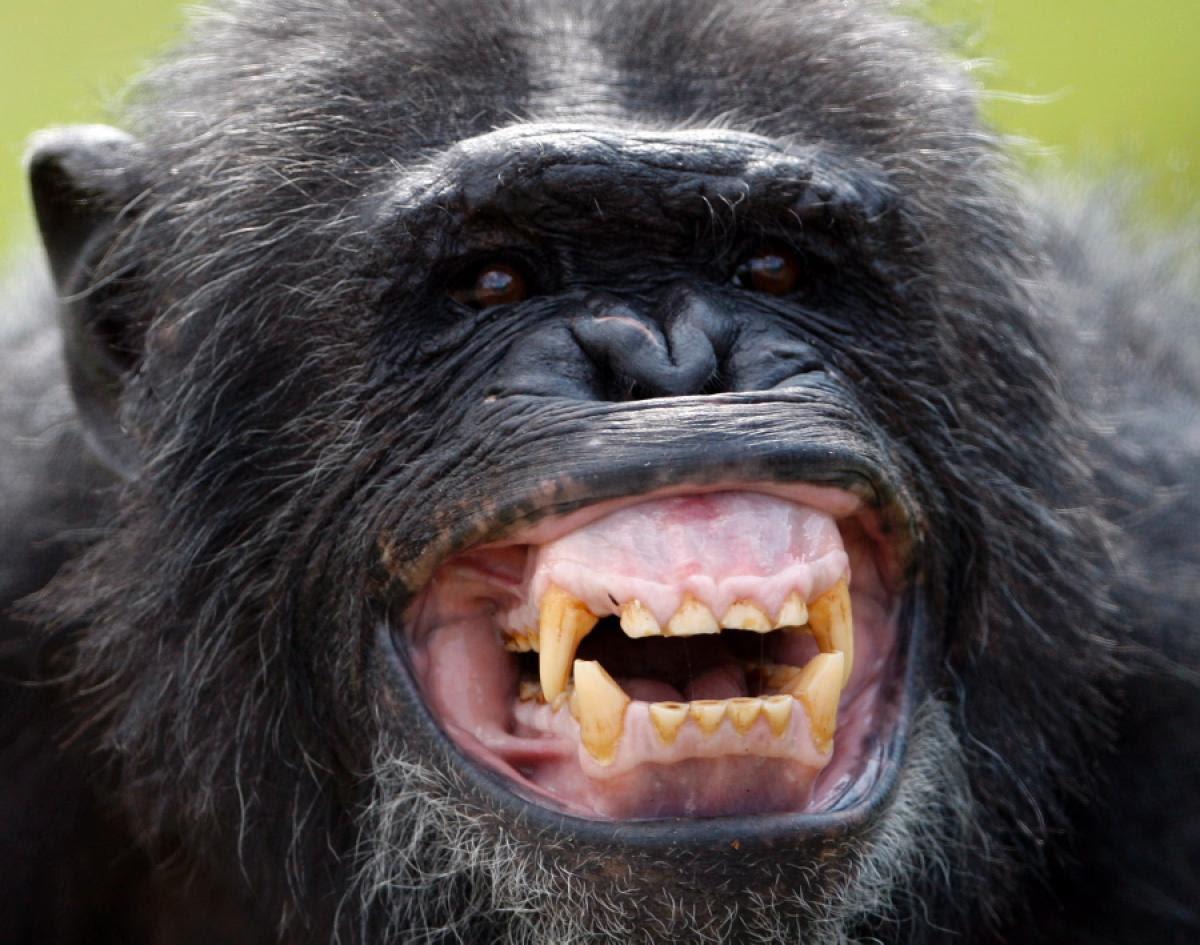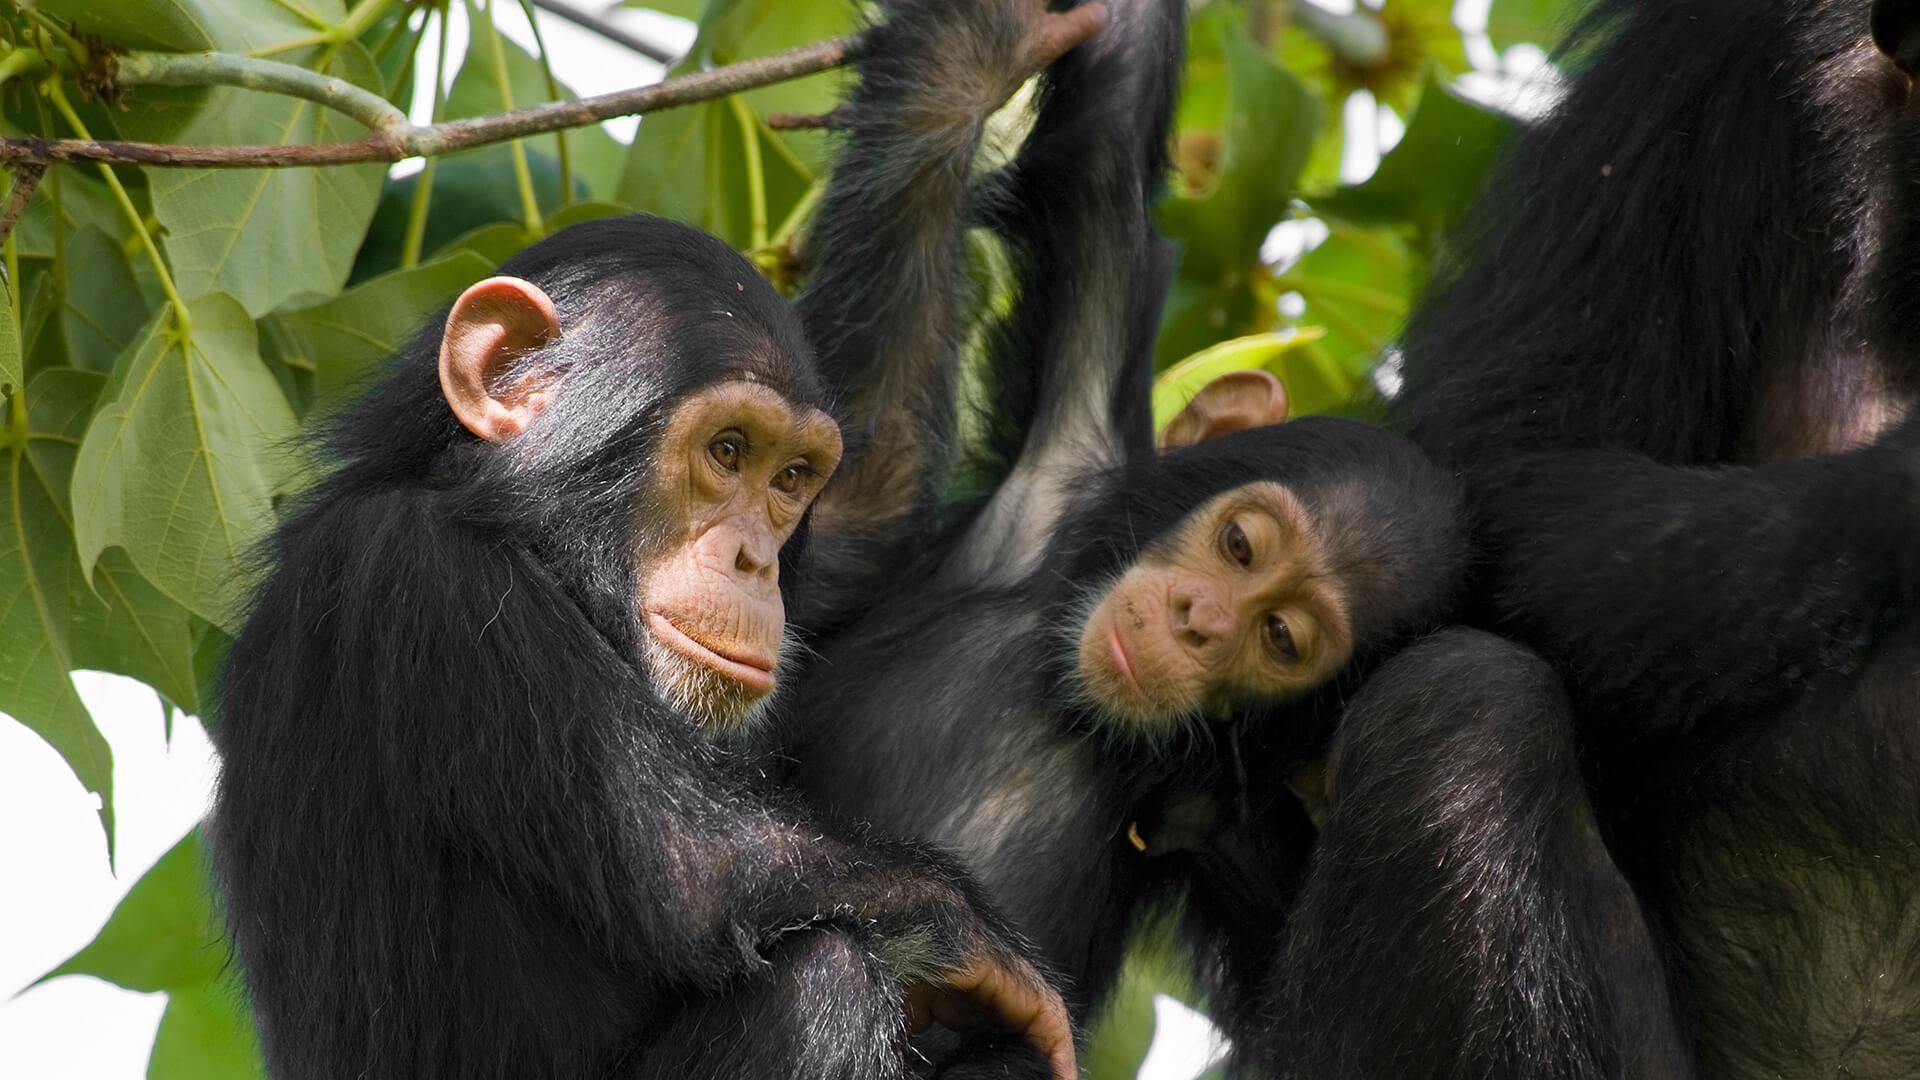The first image is the image on the left, the second image is the image on the right. For the images displayed, is the sentence "One of the images shows only one animal." factually correct? Answer yes or no. Yes. The first image is the image on the left, the second image is the image on the right. Given the left and right images, does the statement "An image shows two very similar looking young chimps side by side." hold true? Answer yes or no. Yes. 